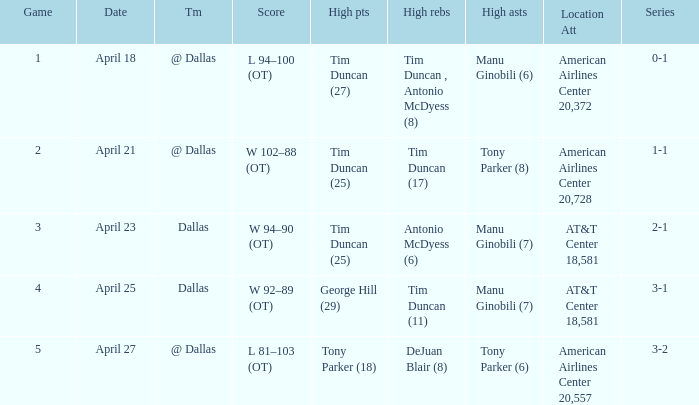When 0-1 is the series who has the highest amount of assists? Manu Ginobili (6). 